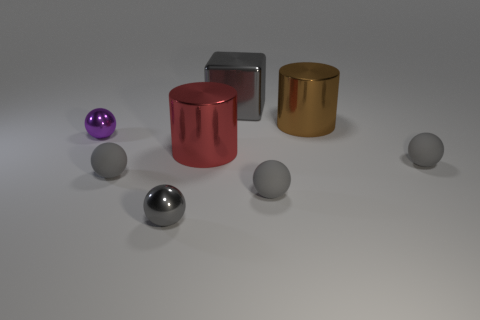Subtract all red cylinders. How many gray spheres are left? 4 Subtract all purple spheres. How many spheres are left? 4 Subtract all purple spheres. How many spheres are left? 4 Subtract all green balls. Subtract all cyan cubes. How many balls are left? 5 Add 1 gray matte cubes. How many objects exist? 9 Subtract all balls. How many objects are left? 3 Subtract all large brown metal cylinders. Subtract all big cylinders. How many objects are left? 5 Add 3 gray balls. How many gray balls are left? 7 Add 5 matte things. How many matte things exist? 8 Subtract 0 green cubes. How many objects are left? 8 